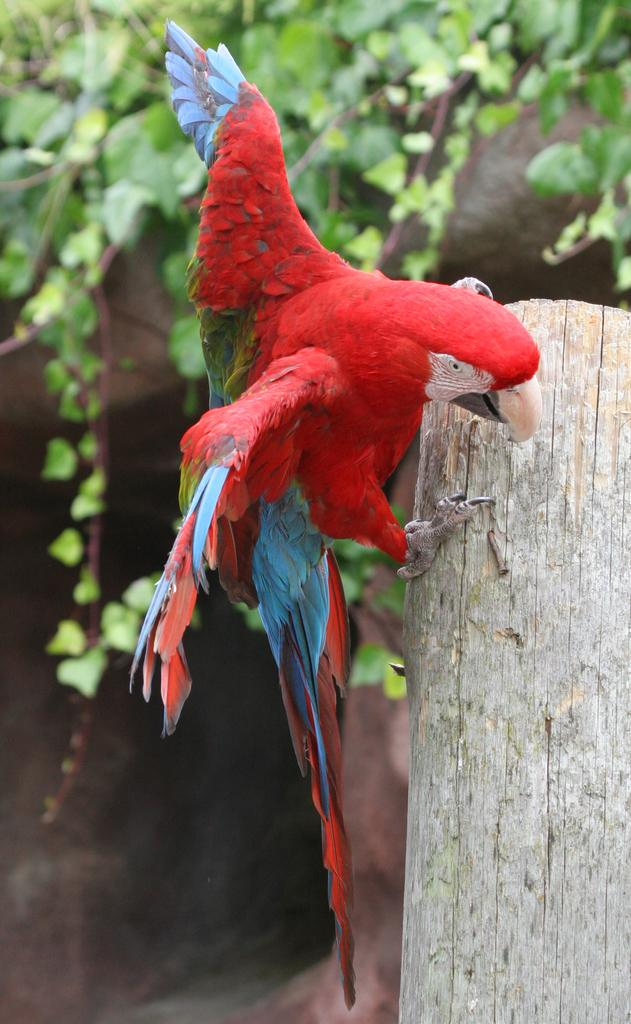What is the main object in the center of the image? There is a piece of wood in the center of the image. What is on top of the piece of wood? There is a macaw on the wood. Can you describe the colors of the macaw? The macaw has green, red, and blue colors. What can be seen in the background of the image? There are trees visible in the background of the image. What type of soap is the macaw using to clean its feathers in the image? There is no soap or indication of the macaw cleaning its feathers in the image. 